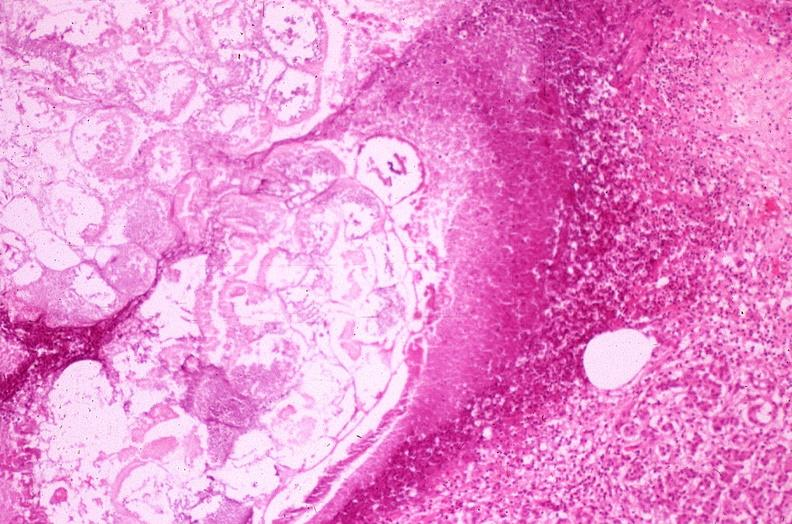where is this?
Answer the question using a single word or phrase. Pancreas 